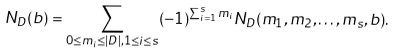<formula> <loc_0><loc_0><loc_500><loc_500>N _ { D } ( b ) = \sum _ { 0 \leq m _ { i } \leq | D | , 1 \leq i \leq s } ( - 1 ) ^ { \sum _ { i = 1 } ^ { s } m _ { i } } N _ { D } ( m _ { 1 } , m _ { 2 } , \dots , m _ { s } , b ) .</formula> 